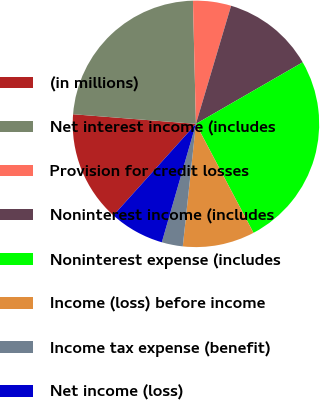Convert chart to OTSL. <chart><loc_0><loc_0><loc_500><loc_500><pie_chart><fcel>(in millions)<fcel>Net interest income (includes<fcel>Provision for credit losses<fcel>Noninterest income (includes<fcel>Noninterest expense (includes<fcel>Income (loss) before income<fcel>Income tax expense (benefit)<fcel>Net income (loss)<nl><fcel>14.57%<fcel>23.37%<fcel>4.99%<fcel>12.07%<fcel>25.59%<fcel>9.44%<fcel>2.76%<fcel>7.21%<nl></chart> 